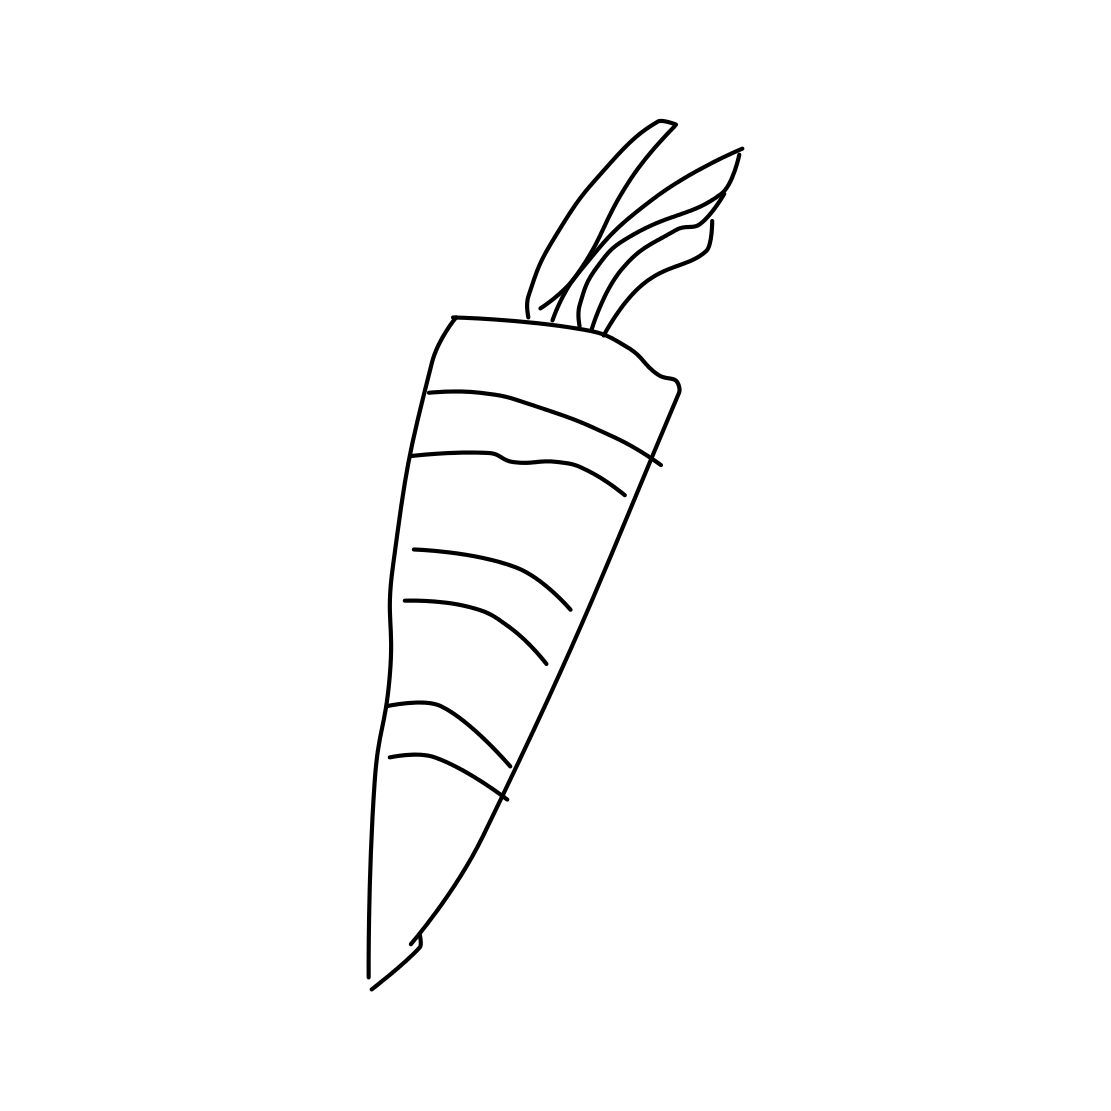Is this a carrot in the image? Yes, the image does indeed depict a carrot characterized by its elongated and tapered shape, typical of common carrots used in cooking. The simple line drawing style emphasizes the distinctive features of a carrot, making it easily recognizable. 